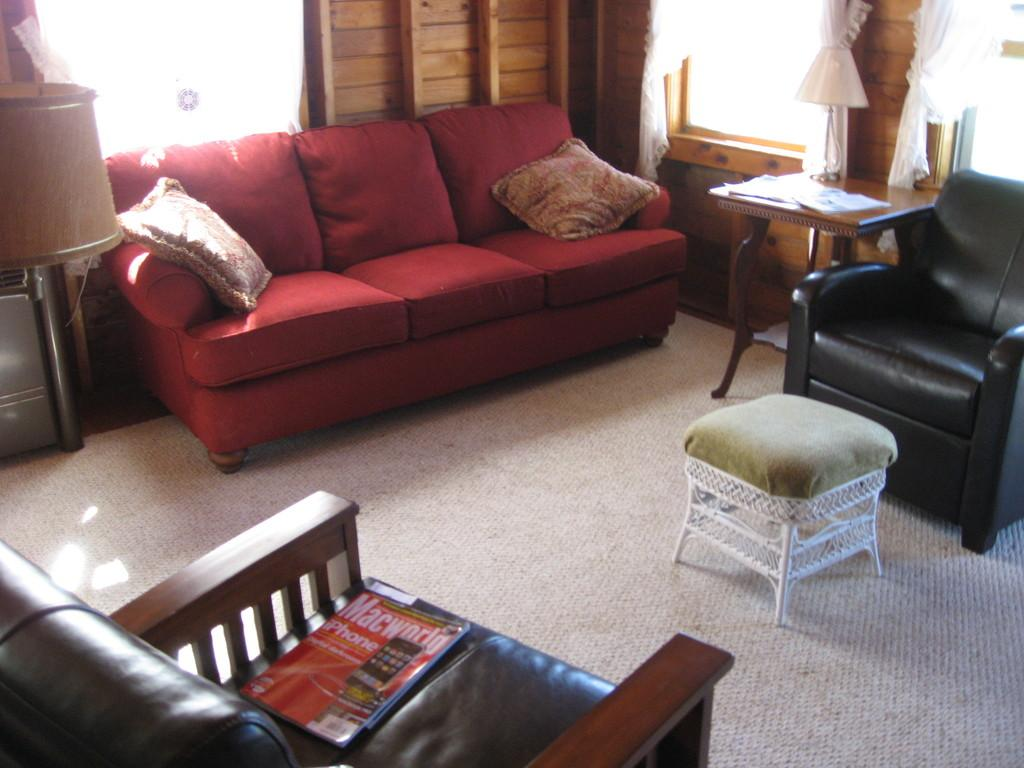What type of space is depicted in the image? The image shows the inner view of a room. What type of seating is available in the room? There is a sofa set, a couch, and chairs in the room. What furniture is present in the room for placing objects? There is a side table in the room. What type of lighting is available in the room? There is a table lamp in the room. What type of decorative items are present in the room? There are cushions in the room. What type of floor covering is present in the room? There is a carpet in the room. What type of natural light source is available in the room? There are windows in the room. What type of rose can be seen growing near the window in the image? There are no roses present in the image; it shows the inner view of a room with furniture and decorative items. What type of shop can be seen through the window in the image? There are no shops visible in the image; it shows the inner view of a room with furniture and decorative items. 